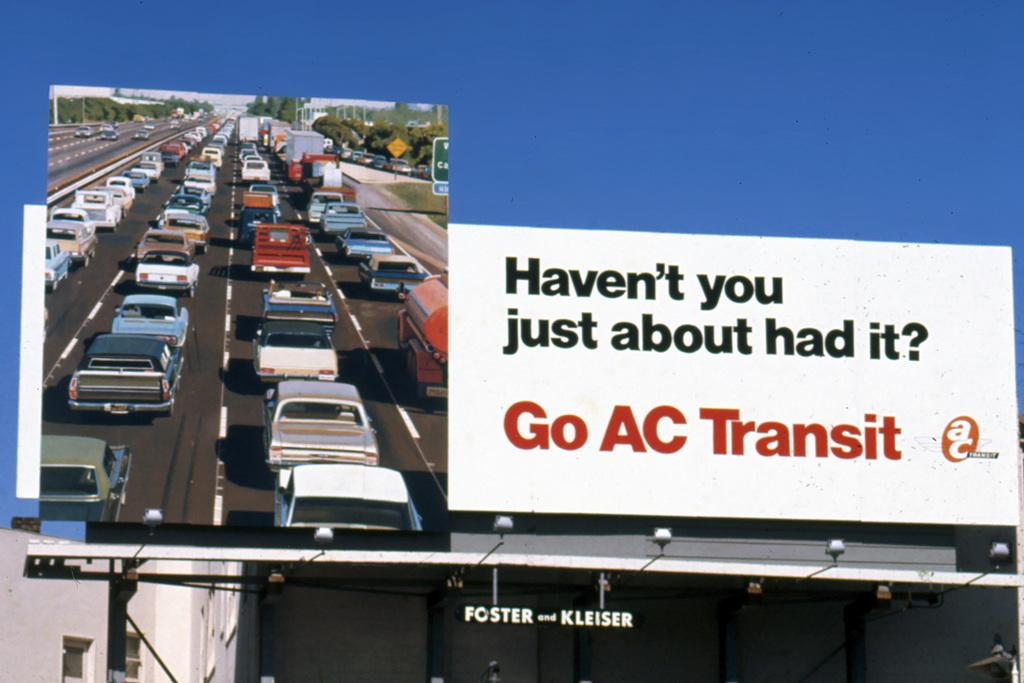Provide a one-sentence caption for the provided image. A billboard for AC Transit shows a traffic jam. 